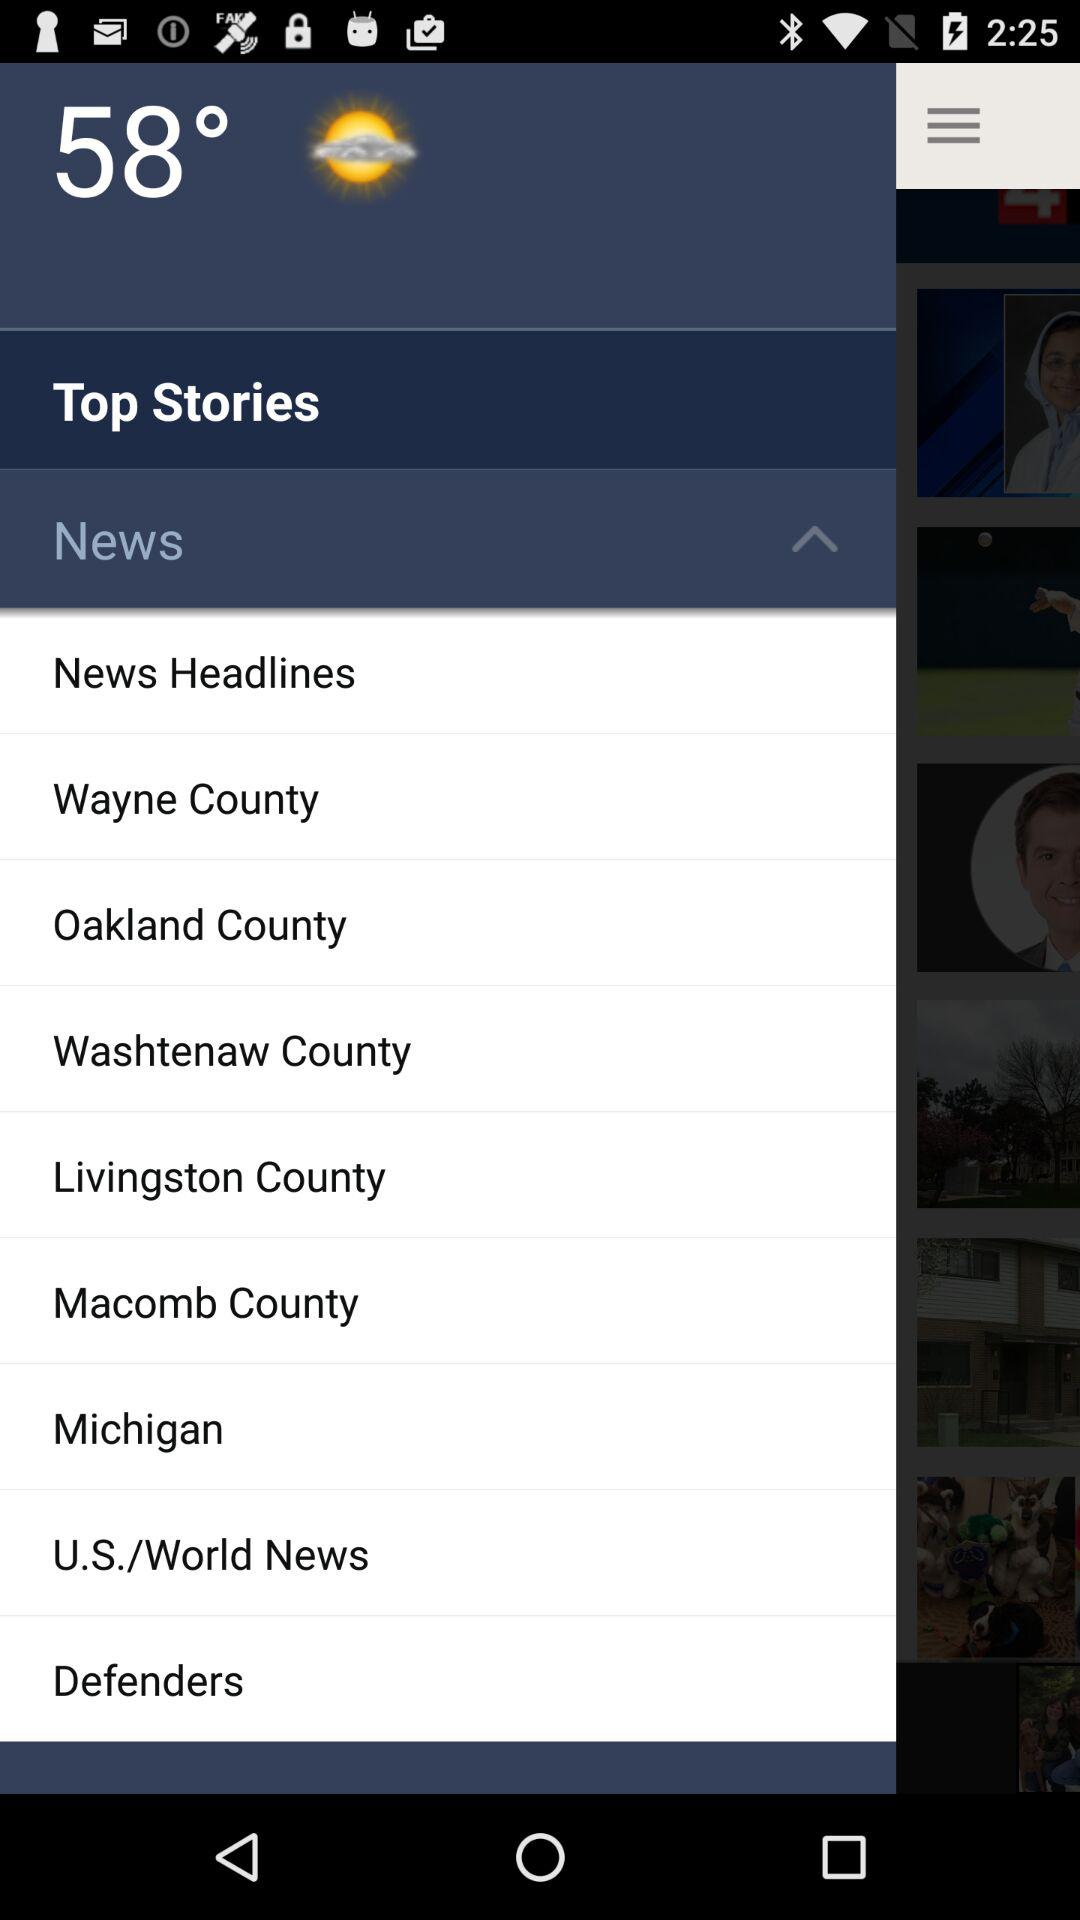What is the given temperature? The given temperature is 58°. 